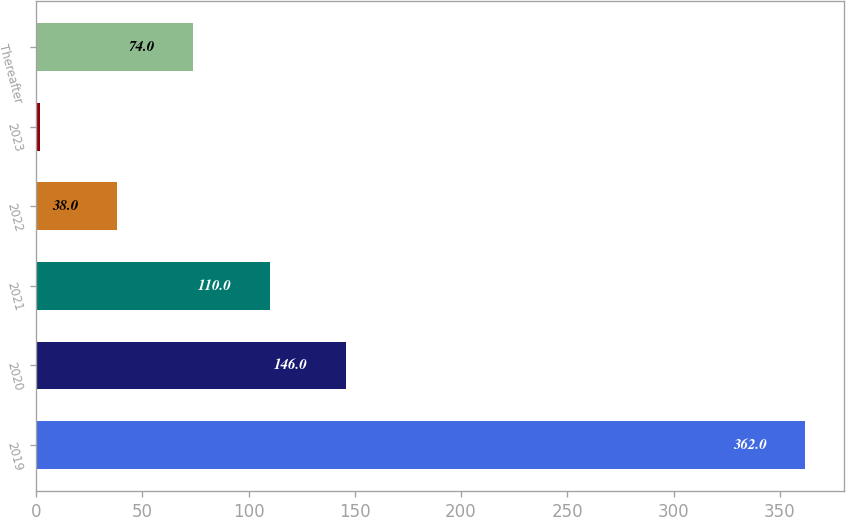Convert chart. <chart><loc_0><loc_0><loc_500><loc_500><bar_chart><fcel>2019<fcel>2020<fcel>2021<fcel>2022<fcel>2023<fcel>Thereafter<nl><fcel>362<fcel>146<fcel>110<fcel>38<fcel>2<fcel>74<nl></chart> 